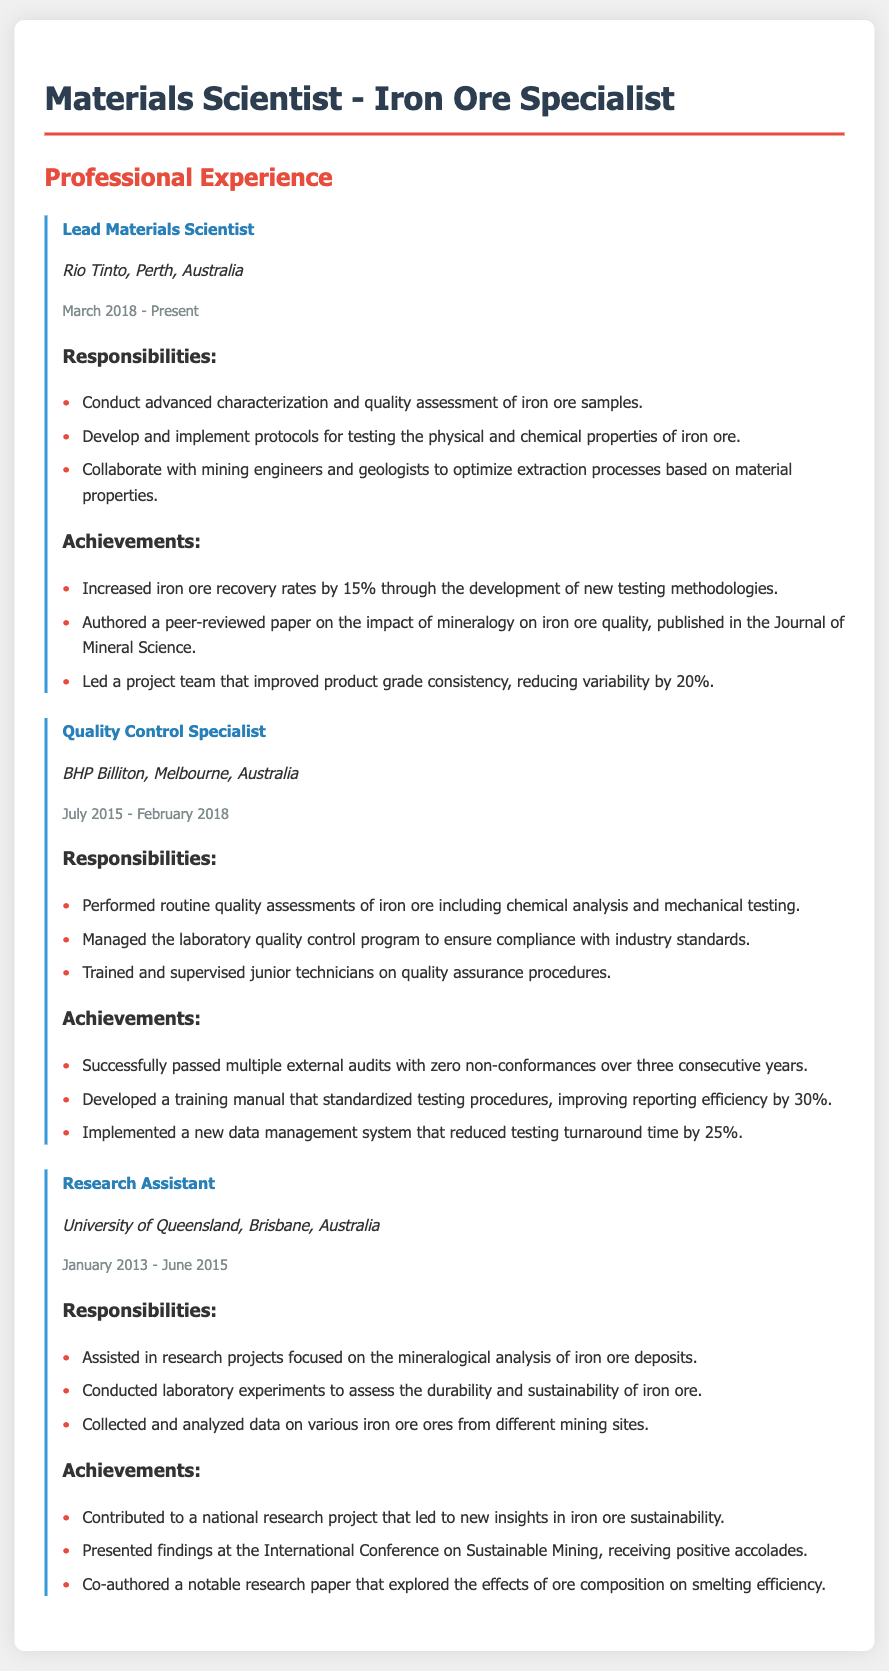What is the job title of the most recent position? The job title is the first item listed under the Professional Experience section, which is "Lead Materials Scientist."
Answer: Lead Materials Scientist When did the candidate start working at Rio Tinto? The start date of employment at Rio Tinto is found in the duration section, which states "March 2018."
Answer: March 2018 How many years did the candidate work as a Research Assistant? The duration of employment as a Research Assistant is listed as "January 2013 - June 2015," which is 2 years and 5 months.
Answer: 2 years and 5 months What is one of the key responsibilities of the Quality Control Specialist? The responsibilities are listed under the Quality Control Specialist section, and one key responsibility is "Performed routine quality assessments of iron ore including chemical analysis and mechanical testing."
Answer: Performed routine quality assessments What was the percentage increase in iron ore recovery rates achieved by the candidate? The achievement section for the Lead Materials Scientist mentions "Increased iron ore recovery rates by 15%."
Answer: 15% Which company did the candidate work for before joining Rio Tinto? The company prior to Rio Tinto is stated in the section for Quality Control Specialist, which is "BHP Billiton."
Answer: BHP Billiton What notable paper did the candidate author? The achievements section under Lead Materials Scientist states, "Authored a peer-reviewed paper on the impact of mineralogy on iron ore quality."
Answer: Authored a peer-reviewed paper What was the improvement in reporting efficiency due to the training manual developed? The achievement under Quality Control Specialist mentions a "30% improvement in reporting efficiency."
Answer: 30% How many consecutive years did the candidate pass external audits with zero non-conformances? This information is given in the achievements section for Quality Control Specialist, stating "multiple external audits with zero non-conformances over three consecutive years."
Answer: Three consecutive years 